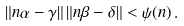Convert formula to latex. <formula><loc_0><loc_0><loc_500><loc_500>\| n \alpha - \gamma \| \, \| n \beta - \delta \| < \psi ( n ) \, .</formula> 